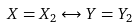Convert formula to latex. <formula><loc_0><loc_0><loc_500><loc_500>X = X _ { 2 } \leftrightarrow Y = Y _ { 2 }</formula> 